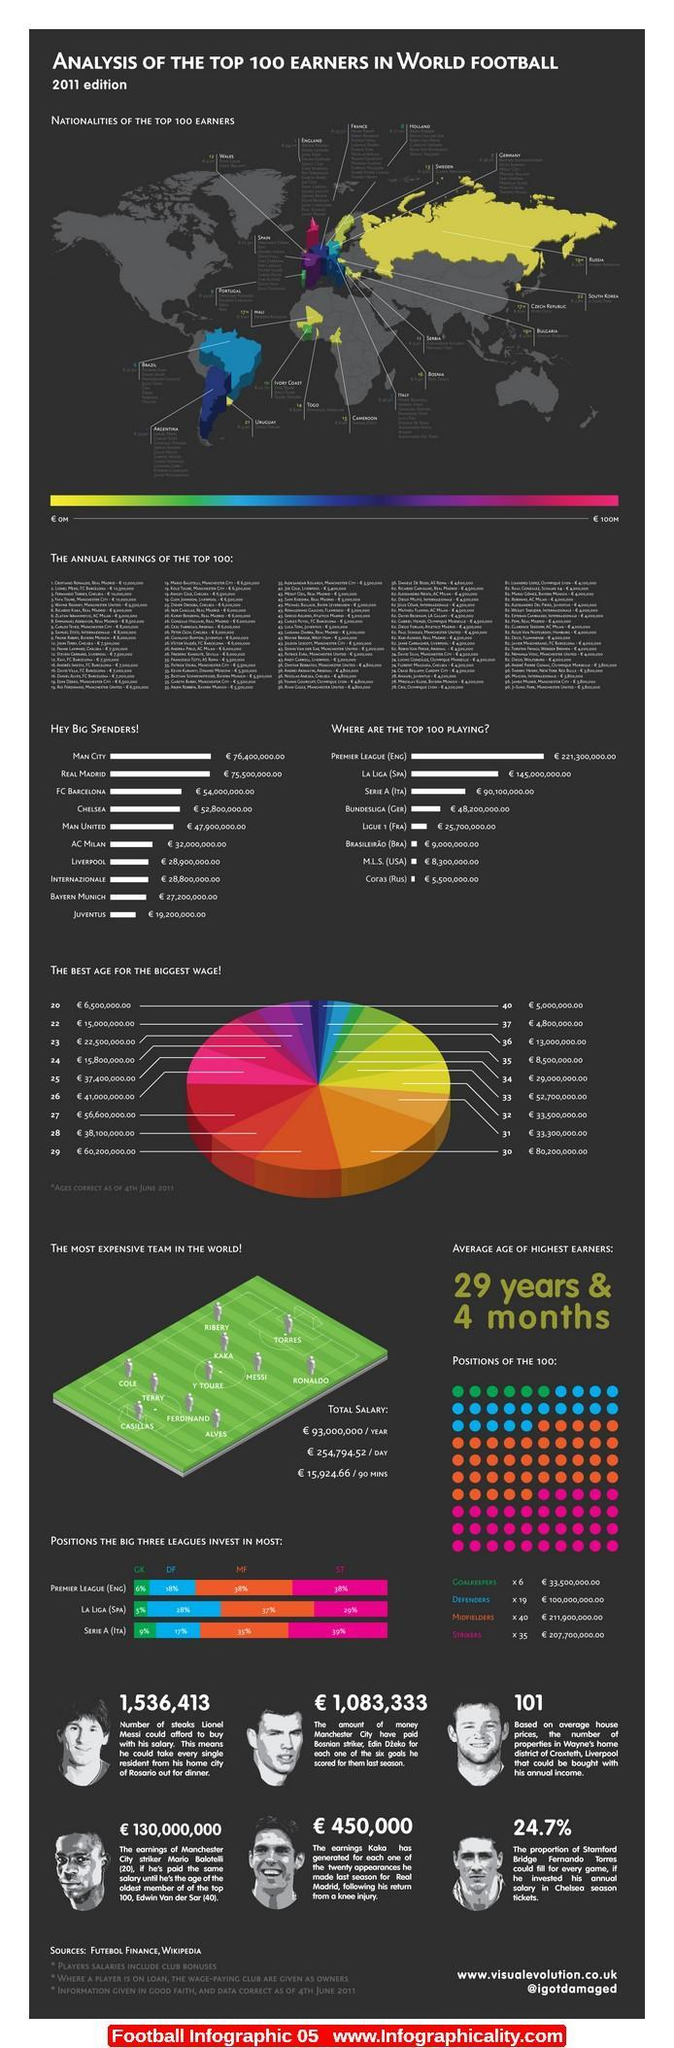What percentage does the Premier League (ENG) invest for midfielders?
Answer the question with a short phrase. 38% What percentage does the La Liga (SPA) invest for midfielders? 37% What is the second best age for the biggest wage? 29 What position do the big three leagues invest in least? Goalkeepers Who spends the least in the big spender list? Juventus What is the third best age for the biggest wage? 27 Who is the fifth Best Big spender? MAN United What is the best age for the biggest wage? 30 Who is the third Best Big spender? FC Barcelona Who is the sixth Best Big spender? AC Milan Who is the fourth Best Big spender? Chelsea Who is the second last in the big spender list? Bayern Munich 